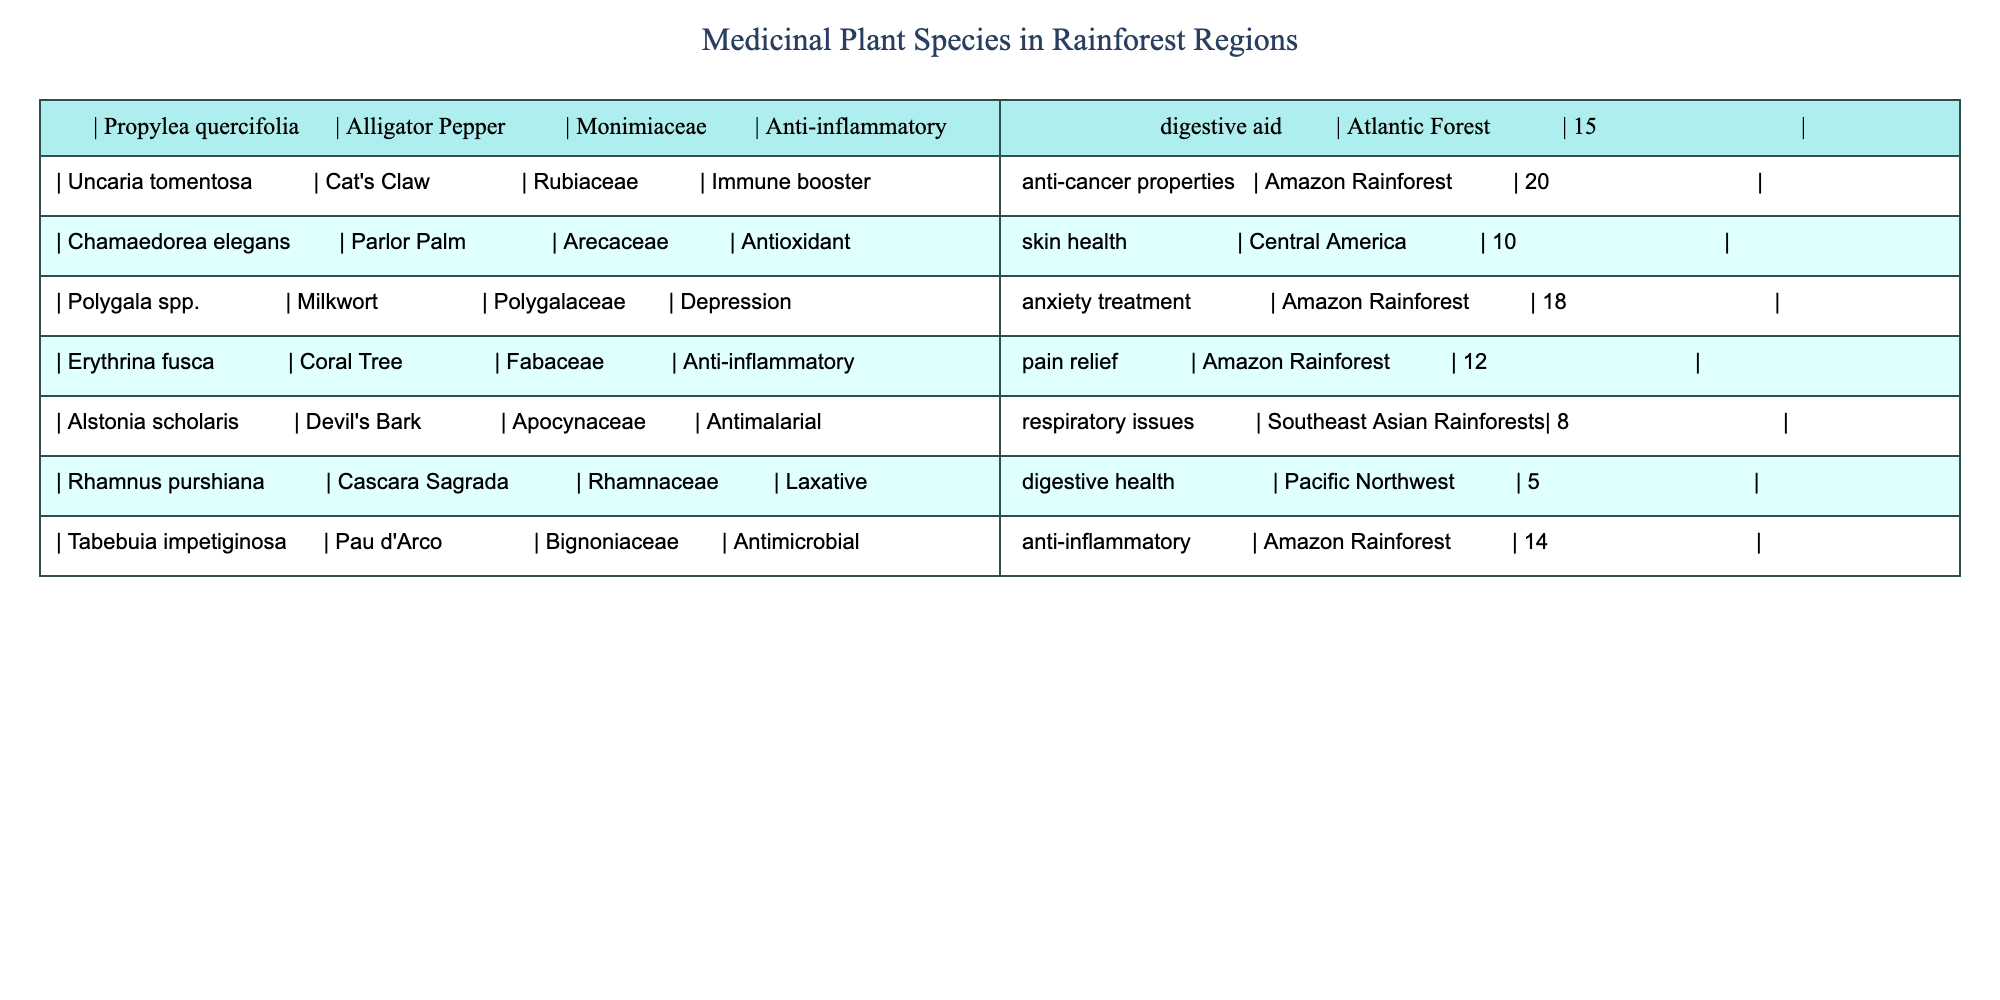What is the common name for Propylea quercifolia? The table lists the scientific name "Propylea quercifolia" along with its common name "Alligator Pepper."
Answer: Alligator Pepper How many medicinal plant species are utilized in the Pacific Northwest? The table shows that "Rhamnus purshiana," a medicinal plant species used in the Pacific Northwest, has a frequency of 5. Therefore, the total number of species listed for that region is 1.
Answer: 1 Which medicinal plant species has the highest frequency of usage? By inspecting the table, "Uncaria tomentosa" has a frequency of 20, which is higher than the others.
Answer: Uncaria tomentosa What are the medicinal properties of Tabebuia impetiginosa? The table specifies that "Tabebuia impetiginosa" is known for its antimicrobial and anti-inflammatory properties.
Answer: Antimicrobial, anti-inflammatory What is the average frequency of the medicinal plant species listed for the Amazon Rainforest? There are three species: "Uncaria tomentosa" (20), "Polygala spp." (18), and "Tabebuia impetiginosa" (14). The sum is 20 + 18 + 14 = 52, and there are 3 species; thus, the average is 52/3 = approximately 17.33.
Answer: 17.33 Is Erythrina fusca used for anti-inflammatory properties? The table indicates that "Erythrina fusca" is categorized under anti-inflammatory and pain relief. Therefore, the statement is true.
Answer: Yes Which plant species belongs to the Fabaceae family? The table shows that "Erythrina fusca" is the only species listed under the Fabaceae family.
Answer: Erythrina fusca How many different families are represented in the table? The table indicates that there are 6 different plant families present: Monimiaceae, Rubiaceae, Arecaceae, Polygalaceae, Fabaceae, Apocynaceae, Rhamnaceae, and Bignoniaceae, totaling 8 families.
Answer: 8 Does Alstonia scholaris have any anti-cancer properties? According to the table, "Alstonia scholaris" is linked to antimalarial and respiratory health but does not mention anti-cancer properties. Therefore, the statement is false.
Answer: No 